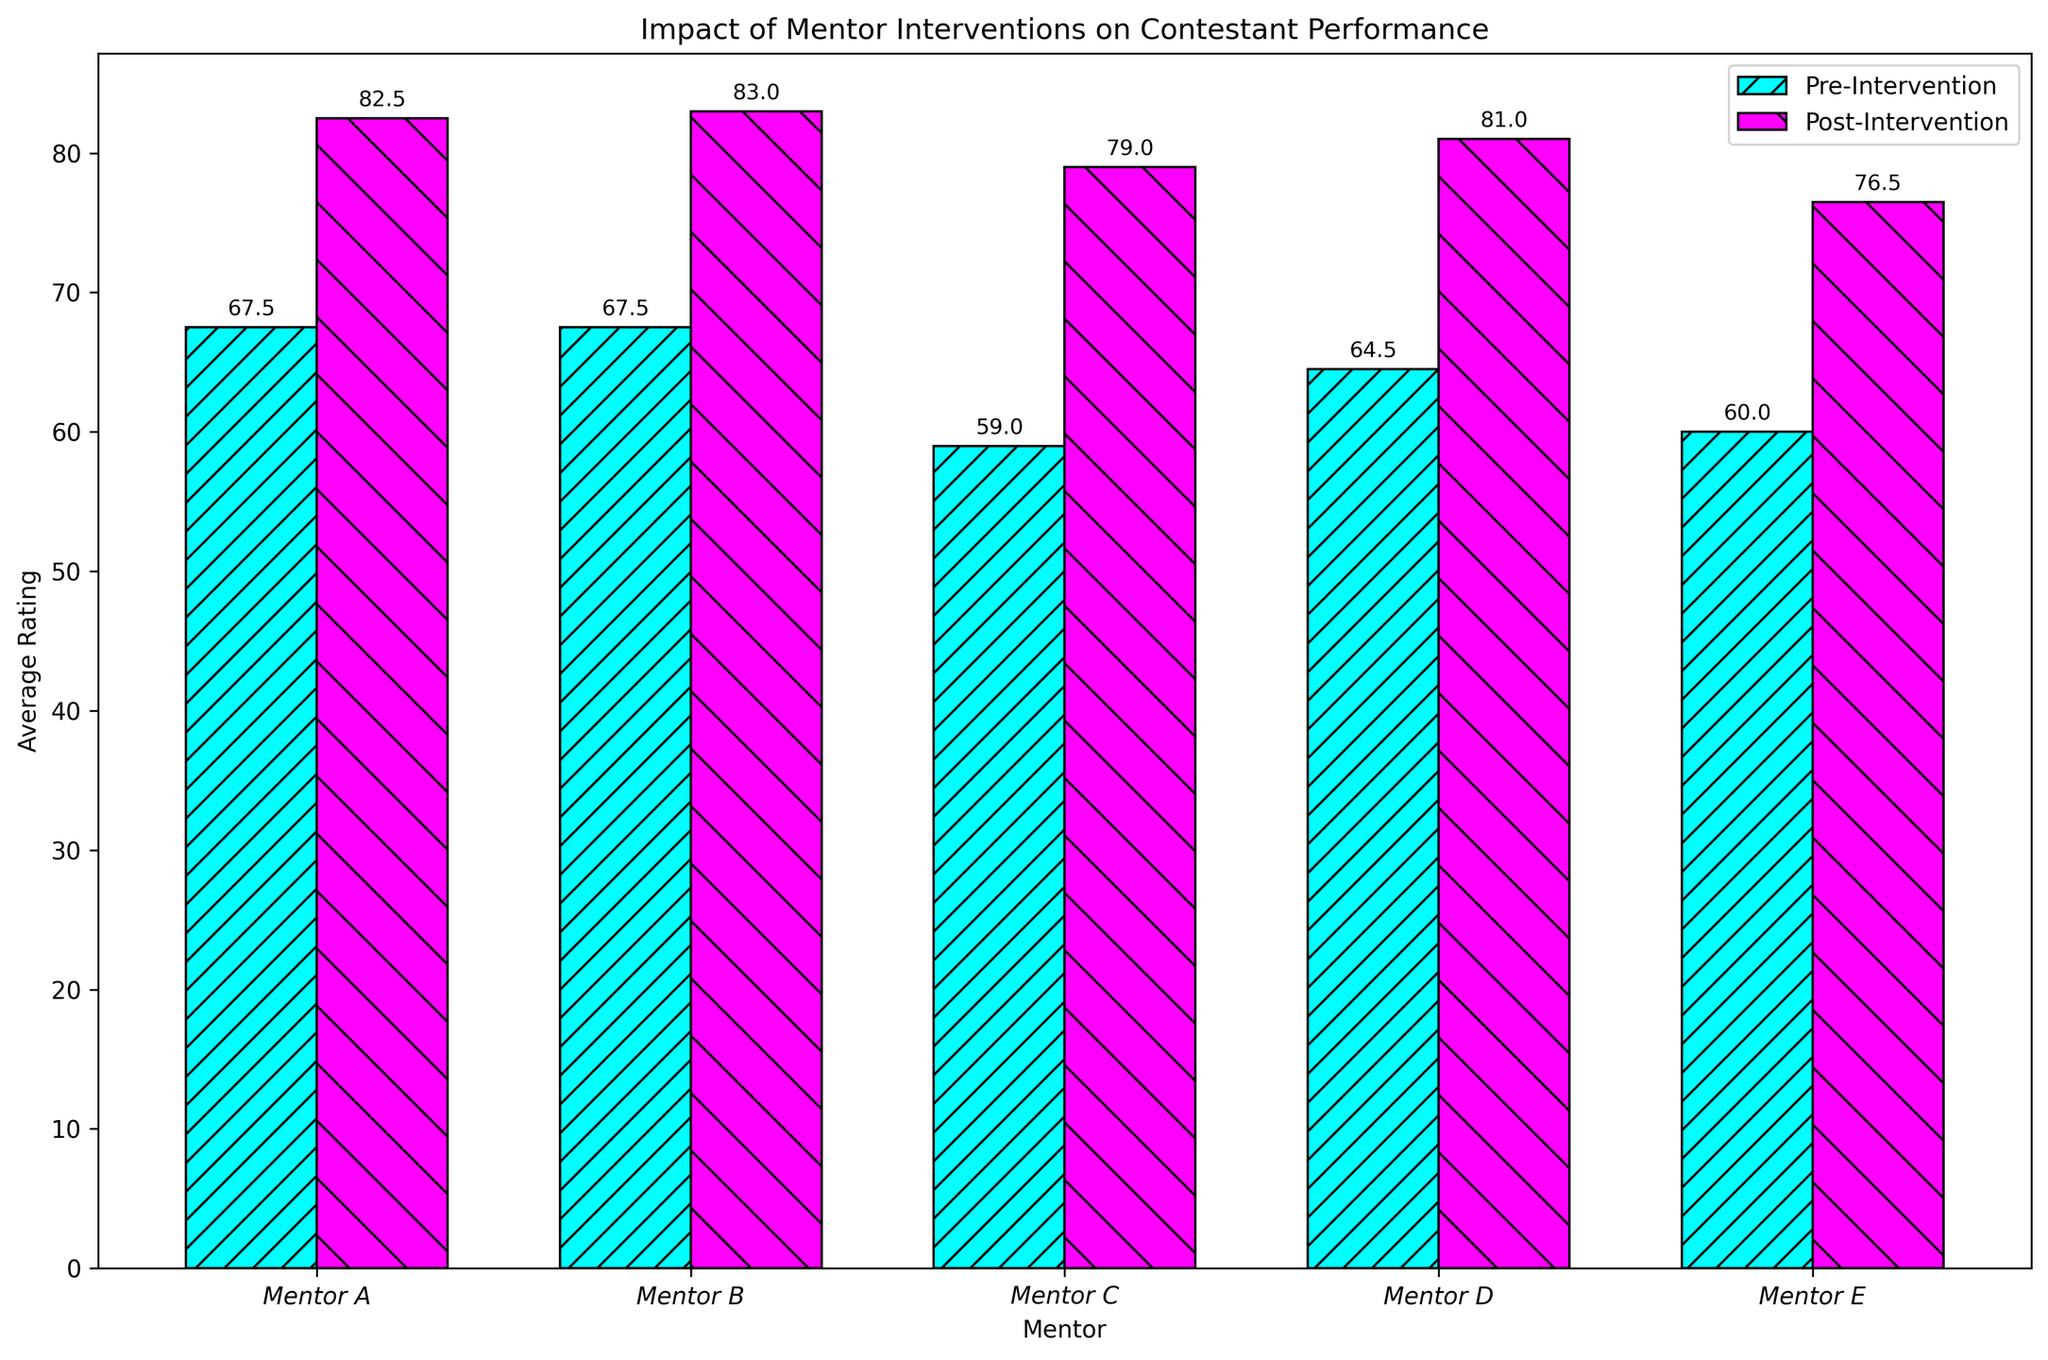Which mentor has the highest average post-intervention rating? We need to compare the heights of the post-intervention bars for all mentors. By inspecting the figure, Mentor B's bar for post-intervention is the tallest.
Answer: Mentor B How much did the average rating improve for Mentor A's contestants after the intervention? We find the difference between the pre-intervention and post-intervention averages for Mentor A. The pre-intervention average is 67.5 (mean of 65 and 70), and the post-intervention average is 82.5 (mean of 80 and 85). The improvement is 82.5 - 67.5.
Answer: 15 Which mentor shows the smallest improvement in average ratings? We look at the difference between the pre-intervention and post-intervention bars for each mentor. Mentor D shows the smallest gap between pre- and post-intervention averages.
Answer: Mentor D How many mentors had an average post-intervention rating greater than 80? We count the number of mentors whose post-intervention bars are above the 80 mark. Mentors A, B, C, and D all have post-intervention ratings greater than 80.
Answer: 4 What is the difference between the highest and lowest average pre-intervention ratings among all mentors? We identify the highest and lowest pre-intervention bars and calculate the difference. Mentor B has the highest pre-intervention rating (67.5), and Mentor E has the lowest (60). The difference is 67.5 - 60.
Answer: 7.5 Which mentor has the smallest variance between their pre- and post-intervention average ratings? We analyze the visual difference between the pre- and post-intervention bars for each mentor. Mentor D shows the smallest visual difference.
Answer: Mentor D What is the combined average post-intervention rating for all mentors? We sum the post-intervention averages for all mentors and divide by the number of mentors. The post-intervention averages are 82.5, 83, 79, 81, and 76.5. The total is 402, and the average is 402 / 5.
Answer: 80.4 Which mentor had contestants with pre-intervention ratings closest to each other? We check the closeness of the two pre-intervention bars for each mentor. Mentor C's contestants had pre-intervention ratings of 58 and 60, which are closest.
Answer: Mentor C Which mentor had contestants with the highest average rating improvement from pre- to post-intervention? We calculate the improvement for each mentor and compare. Mentor B's contestants show the highest average improvement from 67.5 to 83, which is a 15.5 increase.
Answer: Mentor B What is Mentor E's average improvement in contestant ratings? We calculate the difference between the pre- and post-intervention averages for Mentor E. The pre-intervention average is 60, and the post-intervention average is 76.5. The improvement is 76.5 - 60.
Answer: 16.5 